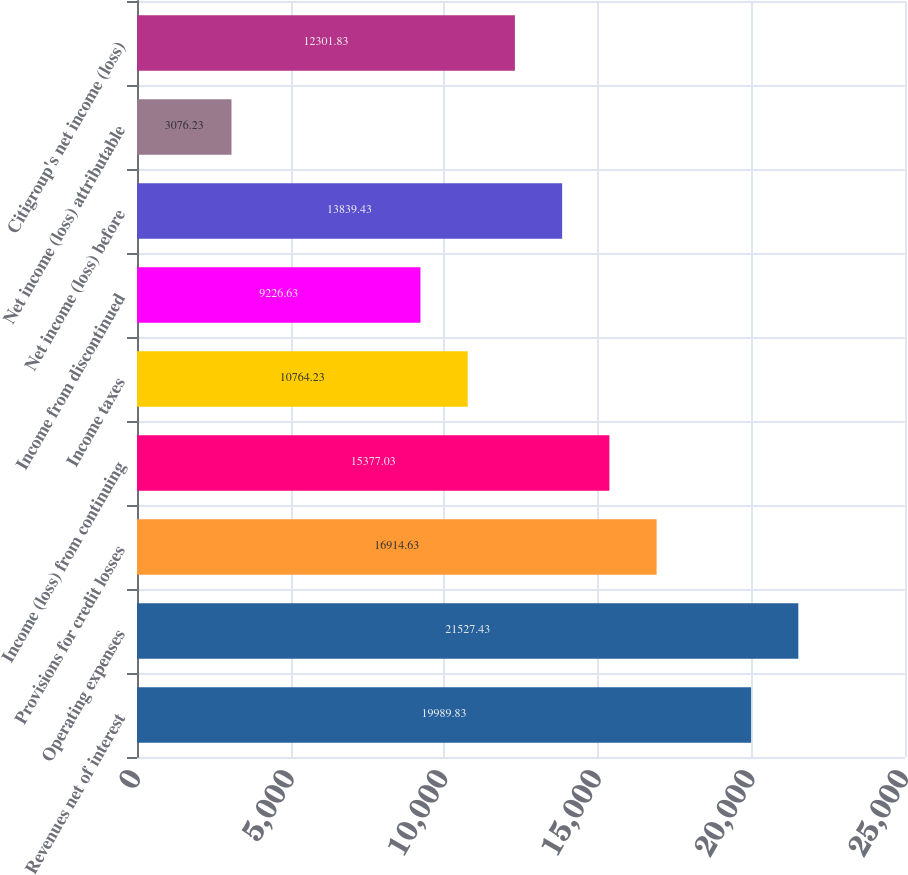Convert chart. <chart><loc_0><loc_0><loc_500><loc_500><bar_chart><fcel>Revenues net of interest<fcel>Operating expenses<fcel>Provisions for credit losses<fcel>Income (loss) from continuing<fcel>Income taxes<fcel>Income from discontinued<fcel>Net income (loss) before<fcel>Net income (loss) attributable<fcel>Citigroup's net income (loss)<nl><fcel>19989.8<fcel>21527.4<fcel>16914.6<fcel>15377<fcel>10764.2<fcel>9226.63<fcel>13839.4<fcel>3076.23<fcel>12301.8<nl></chart> 